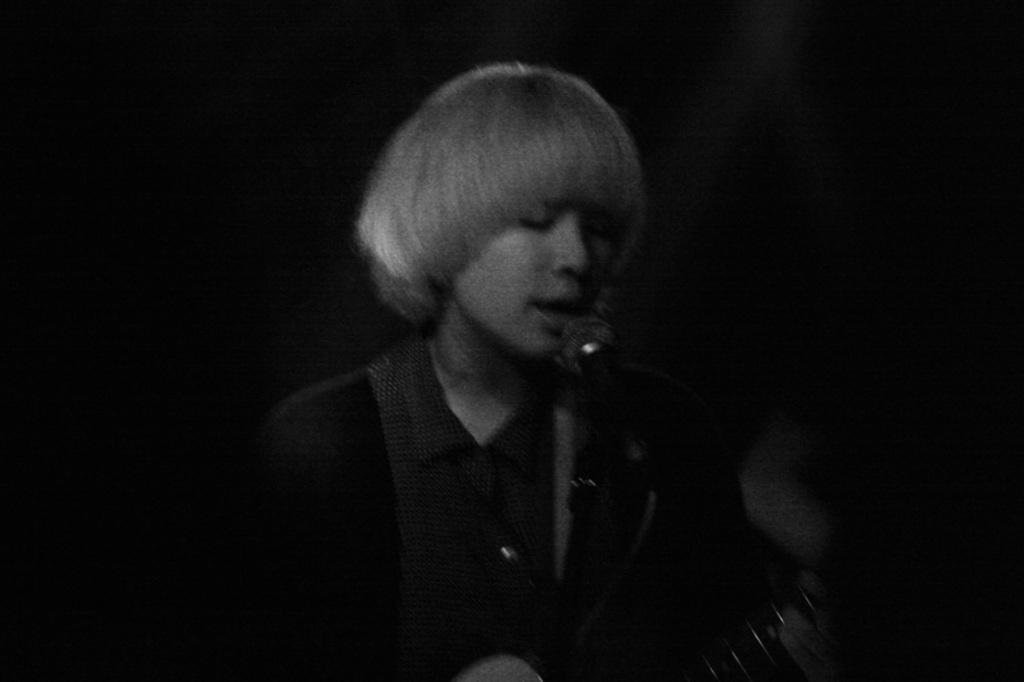Who or what is the main subject in the image? There is a person in the image. What object is visible in the image alongside the person? There is a microphone (mike) in the image. Can you describe the background of the image? The background of the image is dark. How many wool sweaters can be seen in the image? There is no wool sweater present in the image. What type of smile does the person have in the image? The image does not show the person's facial expression, so it cannot be determined if they are smiling or not. 